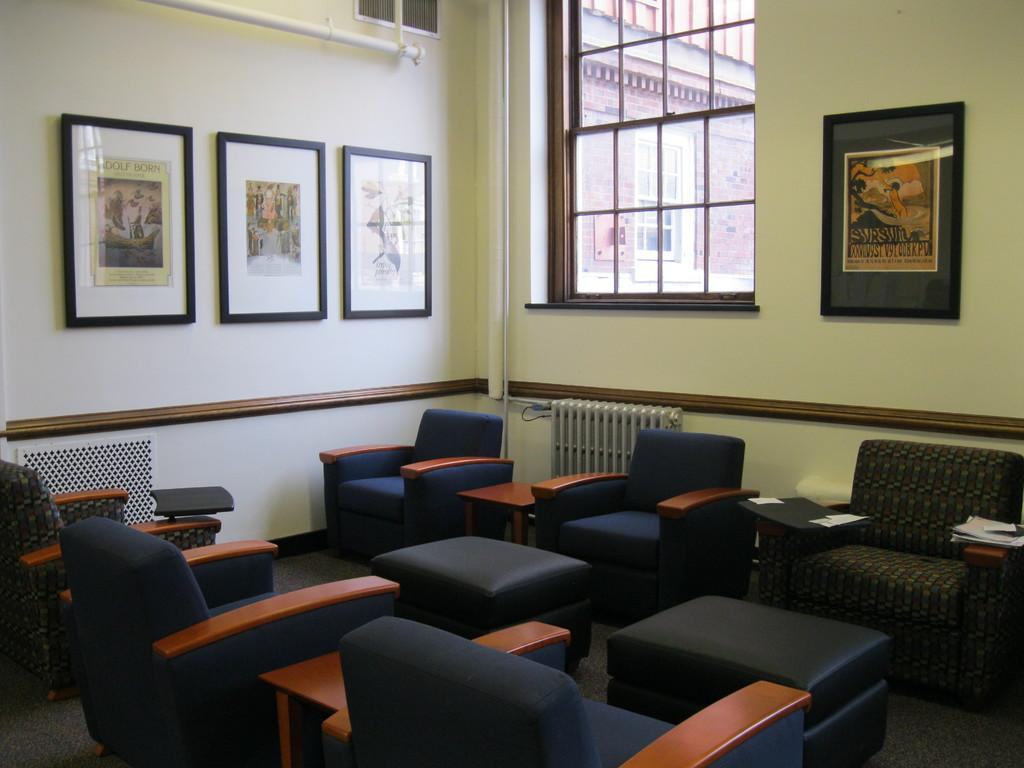What type of furniture is in the foreground of the image? There are sofas in the foreground of the image. How many tables are in the foreground of the image? There are two tables in the foreground of the image. What can be seen hanging on the walls in the image? There are frames visible in the image. What architectural features can be seen in the image? There is a wall and a window in the image. What type of jam is being used for the science experiment in the image? There is no jam or science experiment present in the image. What are the people in the image learning about? There are no people visible in the image, so it cannot be determined what they might be learning about. 